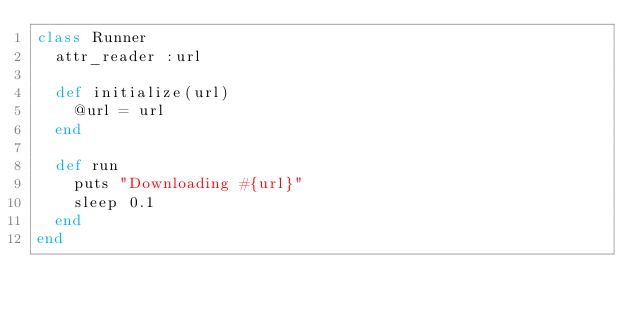<code> <loc_0><loc_0><loc_500><loc_500><_Ruby_>class Runner
  attr_reader :url

  def initialize(url)
    @url = url
  end

  def run
    puts "Downloading #{url}"
    sleep 0.1
  end
end
</code> 